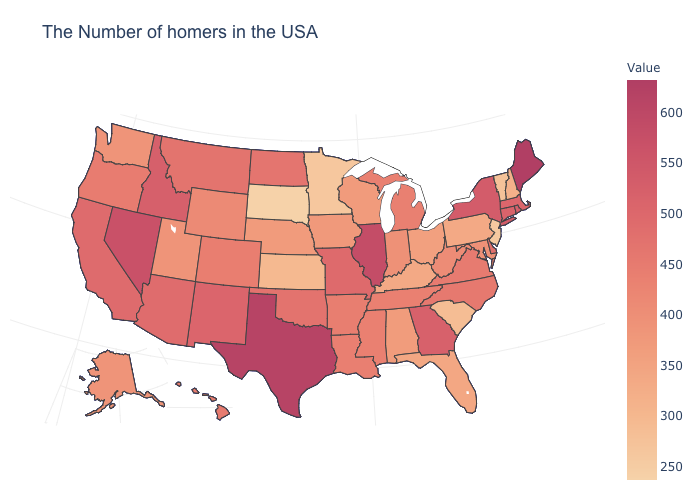Is the legend a continuous bar?
Short answer required. Yes. Does Hawaii have the lowest value in the West?
Answer briefly. No. Which states hav the highest value in the Northeast?
Concise answer only. Maine. Does Maine have a lower value than Arizona?
Concise answer only. No. Does the map have missing data?
Give a very brief answer. No. Which states have the lowest value in the South?
Answer briefly. South Carolina. Which states have the lowest value in the South?
Keep it brief. South Carolina. 